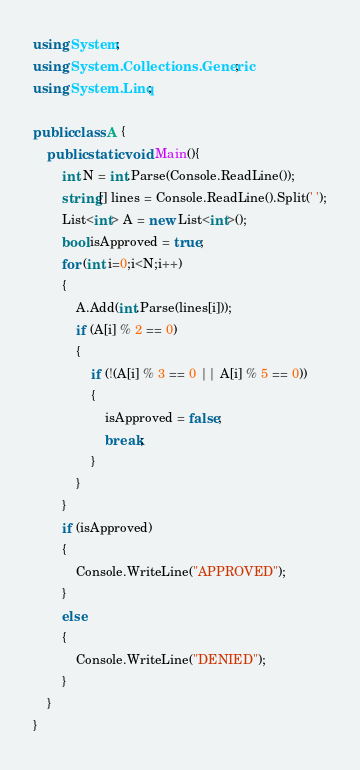<code> <loc_0><loc_0><loc_500><loc_500><_C#_>using System;
using System.Collections.Generic;
using System.Linq;

public class A {
    public static void Main(){
        int N = int.Parse(Console.ReadLine());
        string[] lines = Console.ReadLine().Split(' ');
        List<int> A = new List<int>();
        bool isApproved = true;
        for (int i=0;i<N;i++)
        {
            A.Add(int.Parse(lines[i]));
            if (A[i] % 2 == 0)
            {
                if (!(A[i] % 3 == 0 || A[i] % 5 == 0))
                {
                    isApproved = false;
                    break;
                }
            }
        }
        if (isApproved)
        {
            Console.WriteLine("APPROVED");
        }
        else
        {
            Console.WriteLine("DENIED");
        }
    }
}
</code> 